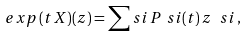<formula> <loc_0><loc_0><loc_500><loc_500>e x p \, ( t \, X ) ( z ) = \sum _ { \ } s i \, P _ { \ } s i ( t ) \, z ^ { \ } s i \, ,</formula> 